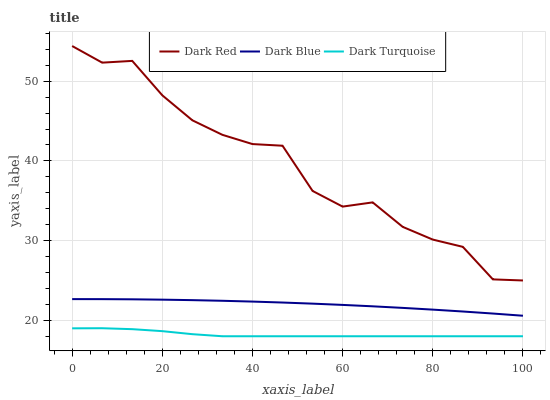Does Dark Turquoise have the minimum area under the curve?
Answer yes or no. Yes. Does Dark Red have the maximum area under the curve?
Answer yes or no. Yes. Does Dark Blue have the minimum area under the curve?
Answer yes or no. No. Does Dark Blue have the maximum area under the curve?
Answer yes or no. No. Is Dark Blue the smoothest?
Answer yes or no. Yes. Is Dark Red the roughest?
Answer yes or no. Yes. Is Dark Turquoise the smoothest?
Answer yes or no. No. Is Dark Turquoise the roughest?
Answer yes or no. No. Does Dark Turquoise have the lowest value?
Answer yes or no. Yes. Does Dark Blue have the lowest value?
Answer yes or no. No. Does Dark Red have the highest value?
Answer yes or no. Yes. Does Dark Blue have the highest value?
Answer yes or no. No. Is Dark Turquoise less than Dark Red?
Answer yes or no. Yes. Is Dark Red greater than Dark Turquoise?
Answer yes or no. Yes. Does Dark Turquoise intersect Dark Red?
Answer yes or no. No. 